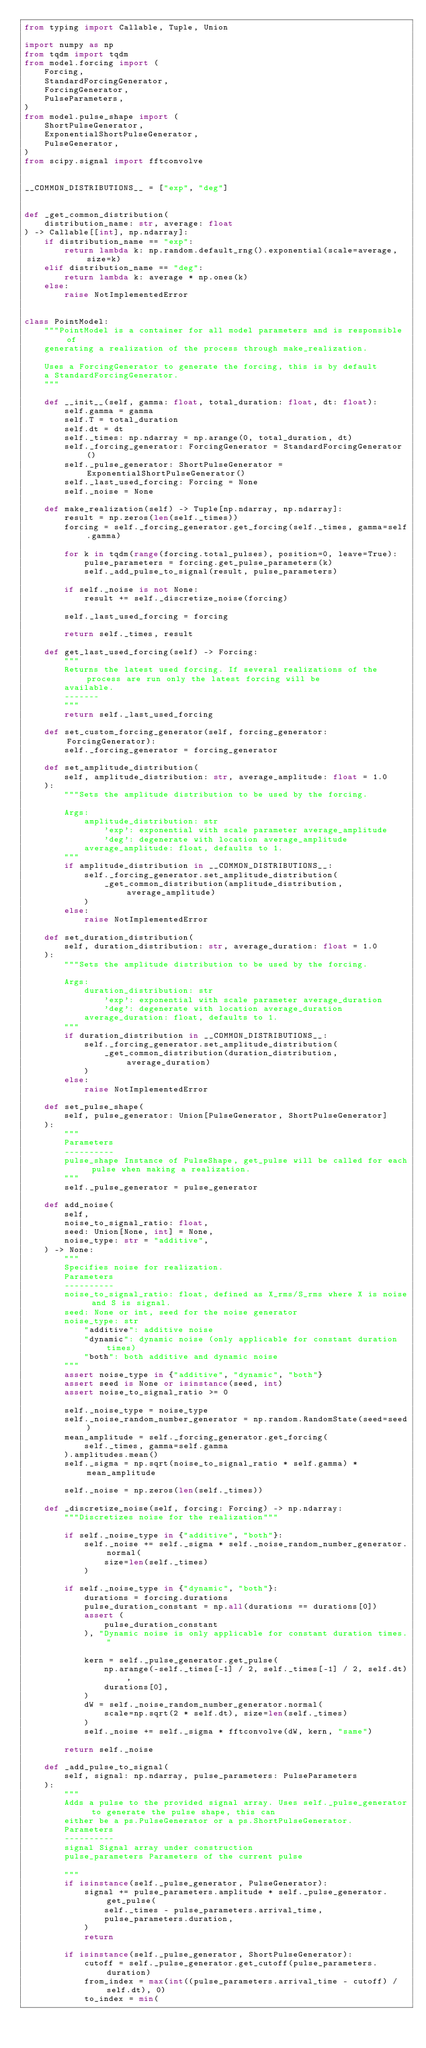<code> <loc_0><loc_0><loc_500><loc_500><_Python_>from typing import Callable, Tuple, Union

import numpy as np
from tqdm import tqdm
from model.forcing import (
    Forcing,
    StandardForcingGenerator,
    ForcingGenerator,
    PulseParameters,
)
from model.pulse_shape import (
    ShortPulseGenerator,
    ExponentialShortPulseGenerator,
    PulseGenerator,
)
from scipy.signal import fftconvolve


__COMMON_DISTRIBUTIONS__ = ["exp", "deg"]


def _get_common_distribution(
    distribution_name: str, average: float
) -> Callable[[int], np.ndarray]:
    if distribution_name == "exp":
        return lambda k: np.random.default_rng().exponential(scale=average, size=k)
    elif distribution_name == "deg":
        return lambda k: average * np.ones(k)
    else:
        raise NotImplementedError


class PointModel:
    """PointModel is a container for all model parameters and is responsible of
    generating a realization of the process through make_realization.

    Uses a ForcingGenerator to generate the forcing, this is by default
    a StandardForcingGenerator.
    """

    def __init__(self, gamma: float, total_duration: float, dt: float):
        self.gamma = gamma
        self.T = total_duration
        self.dt = dt
        self._times: np.ndarray = np.arange(0, total_duration, dt)
        self._forcing_generator: ForcingGenerator = StandardForcingGenerator()
        self._pulse_generator: ShortPulseGenerator = ExponentialShortPulseGenerator()
        self._last_used_forcing: Forcing = None
        self._noise = None

    def make_realization(self) -> Tuple[np.ndarray, np.ndarray]:
        result = np.zeros(len(self._times))
        forcing = self._forcing_generator.get_forcing(self._times, gamma=self.gamma)

        for k in tqdm(range(forcing.total_pulses), position=0, leave=True):
            pulse_parameters = forcing.get_pulse_parameters(k)
            self._add_pulse_to_signal(result, pulse_parameters)

        if self._noise is not None:
            result += self._discretize_noise(forcing)

        self._last_used_forcing = forcing

        return self._times, result

    def get_last_used_forcing(self) -> Forcing:
        """
        Returns the latest used forcing. If several realizations of the process are run only the latest forcing will be
        available.
        -------
        """
        return self._last_used_forcing

    def set_custom_forcing_generator(self, forcing_generator: ForcingGenerator):
        self._forcing_generator = forcing_generator

    def set_amplitude_distribution(
        self, amplitude_distribution: str, average_amplitude: float = 1.0
    ):
        """Sets the amplitude distribution to be used by the forcing.

        Args:
            amplitude_distribution: str
                'exp': exponential with scale parameter average_amplitude
                'deg': degenerate with location average_amplitude
            average_amplitude: float, defaults to 1.
        """
        if amplitude_distribution in __COMMON_DISTRIBUTIONS__:
            self._forcing_generator.set_amplitude_distribution(
                _get_common_distribution(amplitude_distribution, average_amplitude)
            )
        else:
            raise NotImplementedError

    def set_duration_distribution(
        self, duration_distribution: str, average_duration: float = 1.0
    ):
        """Sets the amplitude distribution to be used by the forcing.

        Args:
            duration_distribution: str
                'exp': exponential with scale parameter average_duration
                'deg': degenerate with location average_duration
            average_duration: float, defaults to 1.
        """
        if duration_distribution in __COMMON_DISTRIBUTIONS__:
            self._forcing_generator.set_amplitude_distribution(
                _get_common_distribution(duration_distribution, average_duration)
            )
        else:
            raise NotImplementedError

    def set_pulse_shape(
        self, pulse_generator: Union[PulseGenerator, ShortPulseGenerator]
    ):
        """
        Parameters
        ----------
        pulse_shape Instance of PulseShape, get_pulse will be called for each pulse when making a realization.
        """
        self._pulse_generator = pulse_generator

    def add_noise(
        self,
        noise_to_signal_ratio: float,
        seed: Union[None, int] = None,
        noise_type: str = "additive",
    ) -> None:
        """
        Specifies noise for realization.
        Parameters
        ----------
        noise_to_signal_ratio: float, defined as X_rms/S_rms where X is noise and S is signal.
        seed: None or int, seed for the noise generator
        noise_type: str
            "additive": additive noise
            "dynamic": dynamic noise (only applicable for constant duration times)
            "both": both additive and dynamic noise
        """
        assert noise_type in {"additive", "dynamic", "both"}
        assert seed is None or isinstance(seed, int)
        assert noise_to_signal_ratio >= 0

        self._noise_type = noise_type
        self._noise_random_number_generator = np.random.RandomState(seed=seed)
        mean_amplitude = self._forcing_generator.get_forcing(
            self._times, gamma=self.gamma
        ).amplitudes.mean()
        self._sigma = np.sqrt(noise_to_signal_ratio * self.gamma) * mean_amplitude

        self._noise = np.zeros(len(self._times))

    def _discretize_noise(self, forcing: Forcing) -> np.ndarray:
        """Discretizes noise for the realization"""

        if self._noise_type in {"additive", "both"}:
            self._noise += self._sigma * self._noise_random_number_generator.normal(
                size=len(self._times)
            )

        if self._noise_type in {"dynamic", "both"}:
            durations = forcing.durations
            pulse_duration_constant = np.all(durations == durations[0])
            assert (
                pulse_duration_constant
            ), "Dynamic noise is only applicable for constant duration times."

            kern = self._pulse_generator.get_pulse(
                np.arange(-self._times[-1] / 2, self._times[-1] / 2, self.dt),
                durations[0],
            )
            dW = self._noise_random_number_generator.normal(
                scale=np.sqrt(2 * self.dt), size=len(self._times)
            )
            self._noise += self._sigma * fftconvolve(dW, kern, "same")

        return self._noise

    def _add_pulse_to_signal(
        self, signal: np.ndarray, pulse_parameters: PulseParameters
    ):
        """
        Adds a pulse to the provided signal array. Uses self._pulse_generator to generate the pulse shape, this can
        either be a ps.PulseGenerator or a ps.ShortPulseGenerator.
        Parameters
        ----------
        signal Signal array under construction
        pulse_parameters Parameters of the current pulse

        """
        if isinstance(self._pulse_generator, PulseGenerator):
            signal += pulse_parameters.amplitude * self._pulse_generator.get_pulse(
                self._times - pulse_parameters.arrival_time,
                pulse_parameters.duration,
            )
            return

        if isinstance(self._pulse_generator, ShortPulseGenerator):
            cutoff = self._pulse_generator.get_cutoff(pulse_parameters.duration)
            from_index = max(int((pulse_parameters.arrival_time - cutoff) / self.dt), 0)
            to_index = min(</code> 